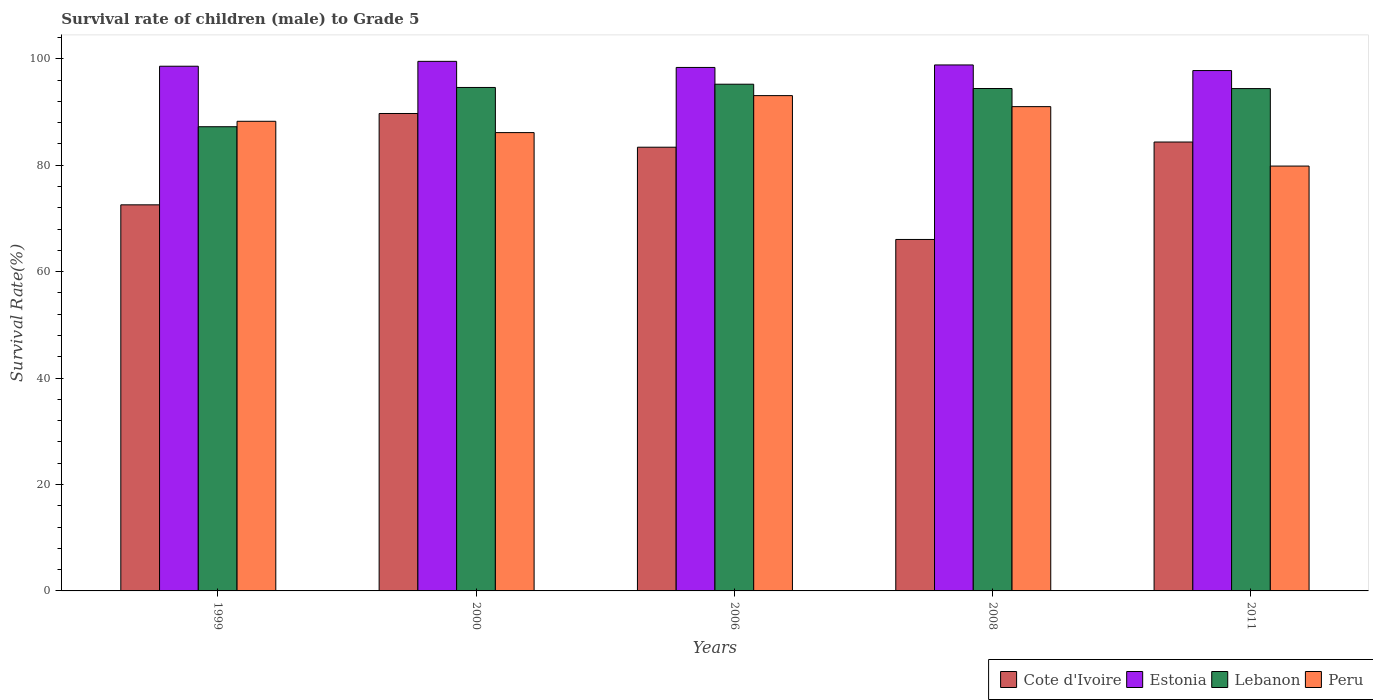How many bars are there on the 4th tick from the left?
Provide a succinct answer. 4. In how many cases, is the number of bars for a given year not equal to the number of legend labels?
Make the answer very short. 0. What is the survival rate of male children to grade 5 in Peru in 1999?
Offer a very short reply. 88.24. Across all years, what is the maximum survival rate of male children to grade 5 in Estonia?
Your answer should be compact. 99.51. Across all years, what is the minimum survival rate of male children to grade 5 in Estonia?
Your answer should be compact. 97.78. In which year was the survival rate of male children to grade 5 in Peru minimum?
Provide a short and direct response. 2011. What is the total survival rate of male children to grade 5 in Peru in the graph?
Your answer should be very brief. 438.26. What is the difference between the survival rate of male children to grade 5 in Lebanon in 1999 and that in 2000?
Make the answer very short. -7.38. What is the difference between the survival rate of male children to grade 5 in Peru in 2011 and the survival rate of male children to grade 5 in Cote d'Ivoire in 2006?
Your answer should be very brief. -3.54. What is the average survival rate of male children to grade 5 in Estonia per year?
Keep it short and to the point. 98.61. In the year 2008, what is the difference between the survival rate of male children to grade 5 in Peru and survival rate of male children to grade 5 in Lebanon?
Keep it short and to the point. -3.41. What is the ratio of the survival rate of male children to grade 5 in Cote d'Ivoire in 1999 to that in 2000?
Provide a succinct answer. 0.81. Is the survival rate of male children to grade 5 in Estonia in 2008 less than that in 2011?
Keep it short and to the point. No. What is the difference between the highest and the second highest survival rate of male children to grade 5 in Lebanon?
Provide a succinct answer. 0.61. What is the difference between the highest and the lowest survival rate of male children to grade 5 in Peru?
Offer a very short reply. 13.24. In how many years, is the survival rate of male children to grade 5 in Lebanon greater than the average survival rate of male children to grade 5 in Lebanon taken over all years?
Ensure brevity in your answer.  4. Is the sum of the survival rate of male children to grade 5 in Peru in 1999 and 2000 greater than the maximum survival rate of male children to grade 5 in Cote d'Ivoire across all years?
Your answer should be compact. Yes. Is it the case that in every year, the sum of the survival rate of male children to grade 5 in Estonia and survival rate of male children to grade 5 in Lebanon is greater than the sum of survival rate of male children to grade 5 in Peru and survival rate of male children to grade 5 in Cote d'Ivoire?
Make the answer very short. No. What does the 1st bar from the left in 2006 represents?
Your response must be concise. Cote d'Ivoire. Are all the bars in the graph horizontal?
Your answer should be compact. No. Are the values on the major ticks of Y-axis written in scientific E-notation?
Provide a short and direct response. No. How many legend labels are there?
Keep it short and to the point. 4. How are the legend labels stacked?
Offer a terse response. Horizontal. What is the title of the graph?
Your answer should be very brief. Survival rate of children (male) to Grade 5. Does "United Arab Emirates" appear as one of the legend labels in the graph?
Your response must be concise. No. What is the label or title of the Y-axis?
Ensure brevity in your answer.  Survival Rate(%). What is the Survival Rate(%) of Cote d'Ivoire in 1999?
Offer a very short reply. 72.55. What is the Survival Rate(%) in Estonia in 1999?
Provide a short and direct response. 98.59. What is the Survival Rate(%) in Lebanon in 1999?
Provide a short and direct response. 87.22. What is the Survival Rate(%) in Peru in 1999?
Provide a succinct answer. 88.24. What is the Survival Rate(%) of Cote d'Ivoire in 2000?
Your response must be concise. 89.71. What is the Survival Rate(%) in Estonia in 2000?
Offer a very short reply. 99.51. What is the Survival Rate(%) of Lebanon in 2000?
Ensure brevity in your answer.  94.6. What is the Survival Rate(%) in Peru in 2000?
Offer a terse response. 86.12. What is the Survival Rate(%) in Cote d'Ivoire in 2006?
Provide a succinct answer. 83.37. What is the Survival Rate(%) of Estonia in 2006?
Offer a very short reply. 98.36. What is the Survival Rate(%) in Lebanon in 2006?
Your answer should be compact. 95.21. What is the Survival Rate(%) of Peru in 2006?
Your answer should be very brief. 93.07. What is the Survival Rate(%) of Cote d'Ivoire in 2008?
Ensure brevity in your answer.  66.04. What is the Survival Rate(%) of Estonia in 2008?
Keep it short and to the point. 98.83. What is the Survival Rate(%) of Lebanon in 2008?
Your answer should be very brief. 94.4. What is the Survival Rate(%) in Peru in 2008?
Your answer should be compact. 91. What is the Survival Rate(%) in Cote d'Ivoire in 2011?
Offer a terse response. 84.35. What is the Survival Rate(%) of Estonia in 2011?
Offer a terse response. 97.78. What is the Survival Rate(%) of Lebanon in 2011?
Your answer should be very brief. 94.39. What is the Survival Rate(%) in Peru in 2011?
Give a very brief answer. 79.83. Across all years, what is the maximum Survival Rate(%) of Cote d'Ivoire?
Ensure brevity in your answer.  89.71. Across all years, what is the maximum Survival Rate(%) of Estonia?
Offer a very short reply. 99.51. Across all years, what is the maximum Survival Rate(%) in Lebanon?
Offer a very short reply. 95.21. Across all years, what is the maximum Survival Rate(%) in Peru?
Provide a succinct answer. 93.07. Across all years, what is the minimum Survival Rate(%) in Cote d'Ivoire?
Make the answer very short. 66.04. Across all years, what is the minimum Survival Rate(%) in Estonia?
Your answer should be compact. 97.78. Across all years, what is the minimum Survival Rate(%) in Lebanon?
Make the answer very short. 87.22. Across all years, what is the minimum Survival Rate(%) in Peru?
Keep it short and to the point. 79.83. What is the total Survival Rate(%) of Cote d'Ivoire in the graph?
Provide a short and direct response. 396.02. What is the total Survival Rate(%) in Estonia in the graph?
Ensure brevity in your answer.  493.06. What is the total Survival Rate(%) of Lebanon in the graph?
Provide a succinct answer. 465.83. What is the total Survival Rate(%) of Peru in the graph?
Provide a succinct answer. 438.26. What is the difference between the Survival Rate(%) of Cote d'Ivoire in 1999 and that in 2000?
Give a very brief answer. -17.16. What is the difference between the Survival Rate(%) of Estonia in 1999 and that in 2000?
Provide a succinct answer. -0.92. What is the difference between the Survival Rate(%) of Lebanon in 1999 and that in 2000?
Your answer should be very brief. -7.38. What is the difference between the Survival Rate(%) in Peru in 1999 and that in 2000?
Offer a terse response. 2.13. What is the difference between the Survival Rate(%) in Cote d'Ivoire in 1999 and that in 2006?
Provide a succinct answer. -10.83. What is the difference between the Survival Rate(%) of Estonia in 1999 and that in 2006?
Offer a terse response. 0.23. What is the difference between the Survival Rate(%) in Lebanon in 1999 and that in 2006?
Offer a terse response. -7.99. What is the difference between the Survival Rate(%) in Peru in 1999 and that in 2006?
Give a very brief answer. -4.82. What is the difference between the Survival Rate(%) in Cote d'Ivoire in 1999 and that in 2008?
Ensure brevity in your answer.  6.51. What is the difference between the Survival Rate(%) in Estonia in 1999 and that in 2008?
Ensure brevity in your answer.  -0.24. What is the difference between the Survival Rate(%) in Lebanon in 1999 and that in 2008?
Offer a very short reply. -7.18. What is the difference between the Survival Rate(%) of Peru in 1999 and that in 2008?
Keep it short and to the point. -2.75. What is the difference between the Survival Rate(%) in Cote d'Ivoire in 1999 and that in 2011?
Your answer should be very brief. -11.8. What is the difference between the Survival Rate(%) in Estonia in 1999 and that in 2011?
Ensure brevity in your answer.  0.81. What is the difference between the Survival Rate(%) in Lebanon in 1999 and that in 2011?
Make the answer very short. -7.17. What is the difference between the Survival Rate(%) of Peru in 1999 and that in 2011?
Make the answer very short. 8.41. What is the difference between the Survival Rate(%) in Cote d'Ivoire in 2000 and that in 2006?
Your response must be concise. 6.34. What is the difference between the Survival Rate(%) in Estonia in 2000 and that in 2006?
Offer a terse response. 1.15. What is the difference between the Survival Rate(%) in Lebanon in 2000 and that in 2006?
Keep it short and to the point. -0.61. What is the difference between the Survival Rate(%) in Peru in 2000 and that in 2006?
Offer a terse response. -6.95. What is the difference between the Survival Rate(%) of Cote d'Ivoire in 2000 and that in 2008?
Make the answer very short. 23.67. What is the difference between the Survival Rate(%) of Estonia in 2000 and that in 2008?
Keep it short and to the point. 0.67. What is the difference between the Survival Rate(%) of Lebanon in 2000 and that in 2008?
Your response must be concise. 0.19. What is the difference between the Survival Rate(%) of Peru in 2000 and that in 2008?
Offer a very short reply. -4.88. What is the difference between the Survival Rate(%) in Cote d'Ivoire in 2000 and that in 2011?
Provide a short and direct response. 5.36. What is the difference between the Survival Rate(%) in Estonia in 2000 and that in 2011?
Keep it short and to the point. 1.73. What is the difference between the Survival Rate(%) in Lebanon in 2000 and that in 2011?
Offer a very short reply. 0.21. What is the difference between the Survival Rate(%) of Peru in 2000 and that in 2011?
Provide a short and direct response. 6.29. What is the difference between the Survival Rate(%) of Cote d'Ivoire in 2006 and that in 2008?
Provide a succinct answer. 17.33. What is the difference between the Survival Rate(%) of Estonia in 2006 and that in 2008?
Keep it short and to the point. -0.47. What is the difference between the Survival Rate(%) of Lebanon in 2006 and that in 2008?
Keep it short and to the point. 0.81. What is the difference between the Survival Rate(%) of Peru in 2006 and that in 2008?
Keep it short and to the point. 2.07. What is the difference between the Survival Rate(%) of Cote d'Ivoire in 2006 and that in 2011?
Ensure brevity in your answer.  -0.97. What is the difference between the Survival Rate(%) in Estonia in 2006 and that in 2011?
Your answer should be very brief. 0.58. What is the difference between the Survival Rate(%) in Lebanon in 2006 and that in 2011?
Keep it short and to the point. 0.82. What is the difference between the Survival Rate(%) in Peru in 2006 and that in 2011?
Provide a short and direct response. 13.24. What is the difference between the Survival Rate(%) in Cote d'Ivoire in 2008 and that in 2011?
Keep it short and to the point. -18.31. What is the difference between the Survival Rate(%) of Estonia in 2008 and that in 2011?
Provide a short and direct response. 1.05. What is the difference between the Survival Rate(%) in Lebanon in 2008 and that in 2011?
Offer a terse response. 0.01. What is the difference between the Survival Rate(%) in Peru in 2008 and that in 2011?
Give a very brief answer. 11.17. What is the difference between the Survival Rate(%) of Cote d'Ivoire in 1999 and the Survival Rate(%) of Estonia in 2000?
Make the answer very short. -26.96. What is the difference between the Survival Rate(%) in Cote d'Ivoire in 1999 and the Survival Rate(%) in Lebanon in 2000?
Offer a very short reply. -22.05. What is the difference between the Survival Rate(%) of Cote d'Ivoire in 1999 and the Survival Rate(%) of Peru in 2000?
Give a very brief answer. -13.57. What is the difference between the Survival Rate(%) of Estonia in 1999 and the Survival Rate(%) of Lebanon in 2000?
Ensure brevity in your answer.  3.99. What is the difference between the Survival Rate(%) of Estonia in 1999 and the Survival Rate(%) of Peru in 2000?
Ensure brevity in your answer.  12.47. What is the difference between the Survival Rate(%) of Lebanon in 1999 and the Survival Rate(%) of Peru in 2000?
Make the answer very short. 1.1. What is the difference between the Survival Rate(%) of Cote d'Ivoire in 1999 and the Survival Rate(%) of Estonia in 2006?
Offer a terse response. -25.81. What is the difference between the Survival Rate(%) of Cote d'Ivoire in 1999 and the Survival Rate(%) of Lebanon in 2006?
Offer a very short reply. -22.67. What is the difference between the Survival Rate(%) of Cote d'Ivoire in 1999 and the Survival Rate(%) of Peru in 2006?
Ensure brevity in your answer.  -20.52. What is the difference between the Survival Rate(%) of Estonia in 1999 and the Survival Rate(%) of Lebanon in 2006?
Make the answer very short. 3.38. What is the difference between the Survival Rate(%) in Estonia in 1999 and the Survival Rate(%) in Peru in 2006?
Give a very brief answer. 5.52. What is the difference between the Survival Rate(%) in Lebanon in 1999 and the Survival Rate(%) in Peru in 2006?
Ensure brevity in your answer.  -5.85. What is the difference between the Survival Rate(%) in Cote d'Ivoire in 1999 and the Survival Rate(%) in Estonia in 2008?
Ensure brevity in your answer.  -26.29. What is the difference between the Survival Rate(%) of Cote d'Ivoire in 1999 and the Survival Rate(%) of Lebanon in 2008?
Offer a terse response. -21.86. What is the difference between the Survival Rate(%) in Cote d'Ivoire in 1999 and the Survival Rate(%) in Peru in 2008?
Your response must be concise. -18.45. What is the difference between the Survival Rate(%) of Estonia in 1999 and the Survival Rate(%) of Lebanon in 2008?
Offer a very short reply. 4.18. What is the difference between the Survival Rate(%) in Estonia in 1999 and the Survival Rate(%) in Peru in 2008?
Provide a short and direct response. 7.59. What is the difference between the Survival Rate(%) of Lebanon in 1999 and the Survival Rate(%) of Peru in 2008?
Your answer should be compact. -3.78. What is the difference between the Survival Rate(%) in Cote d'Ivoire in 1999 and the Survival Rate(%) in Estonia in 2011?
Ensure brevity in your answer.  -25.23. What is the difference between the Survival Rate(%) of Cote d'Ivoire in 1999 and the Survival Rate(%) of Lebanon in 2011?
Keep it short and to the point. -21.84. What is the difference between the Survival Rate(%) in Cote d'Ivoire in 1999 and the Survival Rate(%) in Peru in 2011?
Provide a short and direct response. -7.28. What is the difference between the Survival Rate(%) in Estonia in 1999 and the Survival Rate(%) in Lebanon in 2011?
Provide a short and direct response. 4.2. What is the difference between the Survival Rate(%) in Estonia in 1999 and the Survival Rate(%) in Peru in 2011?
Offer a terse response. 18.76. What is the difference between the Survival Rate(%) of Lebanon in 1999 and the Survival Rate(%) of Peru in 2011?
Your response must be concise. 7.39. What is the difference between the Survival Rate(%) in Cote d'Ivoire in 2000 and the Survival Rate(%) in Estonia in 2006?
Provide a short and direct response. -8.65. What is the difference between the Survival Rate(%) in Cote d'Ivoire in 2000 and the Survival Rate(%) in Lebanon in 2006?
Give a very brief answer. -5.5. What is the difference between the Survival Rate(%) of Cote d'Ivoire in 2000 and the Survival Rate(%) of Peru in 2006?
Provide a succinct answer. -3.36. What is the difference between the Survival Rate(%) of Estonia in 2000 and the Survival Rate(%) of Lebanon in 2006?
Your response must be concise. 4.29. What is the difference between the Survival Rate(%) of Estonia in 2000 and the Survival Rate(%) of Peru in 2006?
Offer a very short reply. 6.44. What is the difference between the Survival Rate(%) in Lebanon in 2000 and the Survival Rate(%) in Peru in 2006?
Your response must be concise. 1.53. What is the difference between the Survival Rate(%) of Cote d'Ivoire in 2000 and the Survival Rate(%) of Estonia in 2008?
Offer a terse response. -9.12. What is the difference between the Survival Rate(%) in Cote d'Ivoire in 2000 and the Survival Rate(%) in Lebanon in 2008?
Provide a short and direct response. -4.7. What is the difference between the Survival Rate(%) of Cote d'Ivoire in 2000 and the Survival Rate(%) of Peru in 2008?
Offer a terse response. -1.29. What is the difference between the Survival Rate(%) in Estonia in 2000 and the Survival Rate(%) in Lebanon in 2008?
Give a very brief answer. 5.1. What is the difference between the Survival Rate(%) of Estonia in 2000 and the Survival Rate(%) of Peru in 2008?
Your response must be concise. 8.51. What is the difference between the Survival Rate(%) of Lebanon in 2000 and the Survival Rate(%) of Peru in 2008?
Ensure brevity in your answer.  3.6. What is the difference between the Survival Rate(%) of Cote d'Ivoire in 2000 and the Survival Rate(%) of Estonia in 2011?
Ensure brevity in your answer.  -8.07. What is the difference between the Survival Rate(%) in Cote d'Ivoire in 2000 and the Survival Rate(%) in Lebanon in 2011?
Your response must be concise. -4.68. What is the difference between the Survival Rate(%) of Cote d'Ivoire in 2000 and the Survival Rate(%) of Peru in 2011?
Provide a short and direct response. 9.88. What is the difference between the Survival Rate(%) of Estonia in 2000 and the Survival Rate(%) of Lebanon in 2011?
Your answer should be very brief. 5.12. What is the difference between the Survival Rate(%) in Estonia in 2000 and the Survival Rate(%) in Peru in 2011?
Your response must be concise. 19.68. What is the difference between the Survival Rate(%) of Lebanon in 2000 and the Survival Rate(%) of Peru in 2011?
Make the answer very short. 14.77. What is the difference between the Survival Rate(%) in Cote d'Ivoire in 2006 and the Survival Rate(%) in Estonia in 2008?
Offer a terse response. -15.46. What is the difference between the Survival Rate(%) of Cote d'Ivoire in 2006 and the Survival Rate(%) of Lebanon in 2008?
Offer a very short reply. -11.03. What is the difference between the Survival Rate(%) in Cote d'Ivoire in 2006 and the Survival Rate(%) in Peru in 2008?
Provide a short and direct response. -7.63. What is the difference between the Survival Rate(%) of Estonia in 2006 and the Survival Rate(%) of Lebanon in 2008?
Your response must be concise. 3.96. What is the difference between the Survival Rate(%) of Estonia in 2006 and the Survival Rate(%) of Peru in 2008?
Give a very brief answer. 7.36. What is the difference between the Survival Rate(%) in Lebanon in 2006 and the Survival Rate(%) in Peru in 2008?
Ensure brevity in your answer.  4.21. What is the difference between the Survival Rate(%) of Cote d'Ivoire in 2006 and the Survival Rate(%) of Estonia in 2011?
Your response must be concise. -14.41. What is the difference between the Survival Rate(%) of Cote d'Ivoire in 2006 and the Survival Rate(%) of Lebanon in 2011?
Ensure brevity in your answer.  -11.02. What is the difference between the Survival Rate(%) in Cote d'Ivoire in 2006 and the Survival Rate(%) in Peru in 2011?
Make the answer very short. 3.54. What is the difference between the Survival Rate(%) of Estonia in 2006 and the Survival Rate(%) of Lebanon in 2011?
Make the answer very short. 3.97. What is the difference between the Survival Rate(%) of Estonia in 2006 and the Survival Rate(%) of Peru in 2011?
Make the answer very short. 18.53. What is the difference between the Survival Rate(%) of Lebanon in 2006 and the Survival Rate(%) of Peru in 2011?
Make the answer very short. 15.38. What is the difference between the Survival Rate(%) in Cote d'Ivoire in 2008 and the Survival Rate(%) in Estonia in 2011?
Ensure brevity in your answer.  -31.74. What is the difference between the Survival Rate(%) in Cote d'Ivoire in 2008 and the Survival Rate(%) in Lebanon in 2011?
Make the answer very short. -28.35. What is the difference between the Survival Rate(%) of Cote d'Ivoire in 2008 and the Survival Rate(%) of Peru in 2011?
Keep it short and to the point. -13.79. What is the difference between the Survival Rate(%) in Estonia in 2008 and the Survival Rate(%) in Lebanon in 2011?
Your answer should be very brief. 4.44. What is the difference between the Survival Rate(%) of Estonia in 2008 and the Survival Rate(%) of Peru in 2011?
Your answer should be very brief. 19. What is the difference between the Survival Rate(%) in Lebanon in 2008 and the Survival Rate(%) in Peru in 2011?
Make the answer very short. 14.57. What is the average Survival Rate(%) of Cote d'Ivoire per year?
Ensure brevity in your answer.  79.2. What is the average Survival Rate(%) in Estonia per year?
Provide a succinct answer. 98.61. What is the average Survival Rate(%) in Lebanon per year?
Make the answer very short. 93.17. What is the average Survival Rate(%) in Peru per year?
Offer a terse response. 87.65. In the year 1999, what is the difference between the Survival Rate(%) in Cote d'Ivoire and Survival Rate(%) in Estonia?
Ensure brevity in your answer.  -26.04. In the year 1999, what is the difference between the Survival Rate(%) in Cote d'Ivoire and Survival Rate(%) in Lebanon?
Give a very brief answer. -14.68. In the year 1999, what is the difference between the Survival Rate(%) in Cote d'Ivoire and Survival Rate(%) in Peru?
Your answer should be very brief. -15.7. In the year 1999, what is the difference between the Survival Rate(%) in Estonia and Survival Rate(%) in Lebanon?
Offer a very short reply. 11.37. In the year 1999, what is the difference between the Survival Rate(%) of Estonia and Survival Rate(%) of Peru?
Provide a succinct answer. 10.35. In the year 1999, what is the difference between the Survival Rate(%) in Lebanon and Survival Rate(%) in Peru?
Offer a terse response. -1.02. In the year 2000, what is the difference between the Survival Rate(%) in Cote d'Ivoire and Survival Rate(%) in Estonia?
Your answer should be compact. -9.8. In the year 2000, what is the difference between the Survival Rate(%) of Cote d'Ivoire and Survival Rate(%) of Lebanon?
Provide a succinct answer. -4.89. In the year 2000, what is the difference between the Survival Rate(%) of Cote d'Ivoire and Survival Rate(%) of Peru?
Offer a very short reply. 3.59. In the year 2000, what is the difference between the Survival Rate(%) of Estonia and Survival Rate(%) of Lebanon?
Ensure brevity in your answer.  4.91. In the year 2000, what is the difference between the Survival Rate(%) in Estonia and Survival Rate(%) in Peru?
Provide a short and direct response. 13.39. In the year 2000, what is the difference between the Survival Rate(%) of Lebanon and Survival Rate(%) of Peru?
Ensure brevity in your answer.  8.48. In the year 2006, what is the difference between the Survival Rate(%) in Cote d'Ivoire and Survival Rate(%) in Estonia?
Your answer should be very brief. -14.99. In the year 2006, what is the difference between the Survival Rate(%) in Cote d'Ivoire and Survival Rate(%) in Lebanon?
Your response must be concise. -11.84. In the year 2006, what is the difference between the Survival Rate(%) in Cote d'Ivoire and Survival Rate(%) in Peru?
Your response must be concise. -9.7. In the year 2006, what is the difference between the Survival Rate(%) of Estonia and Survival Rate(%) of Lebanon?
Provide a succinct answer. 3.15. In the year 2006, what is the difference between the Survival Rate(%) of Estonia and Survival Rate(%) of Peru?
Offer a terse response. 5.29. In the year 2006, what is the difference between the Survival Rate(%) in Lebanon and Survival Rate(%) in Peru?
Your answer should be compact. 2.14. In the year 2008, what is the difference between the Survival Rate(%) in Cote d'Ivoire and Survival Rate(%) in Estonia?
Offer a terse response. -32.79. In the year 2008, what is the difference between the Survival Rate(%) of Cote d'Ivoire and Survival Rate(%) of Lebanon?
Give a very brief answer. -28.36. In the year 2008, what is the difference between the Survival Rate(%) of Cote d'Ivoire and Survival Rate(%) of Peru?
Offer a very short reply. -24.96. In the year 2008, what is the difference between the Survival Rate(%) of Estonia and Survival Rate(%) of Lebanon?
Offer a terse response. 4.43. In the year 2008, what is the difference between the Survival Rate(%) in Estonia and Survival Rate(%) in Peru?
Ensure brevity in your answer.  7.83. In the year 2008, what is the difference between the Survival Rate(%) in Lebanon and Survival Rate(%) in Peru?
Your answer should be very brief. 3.41. In the year 2011, what is the difference between the Survival Rate(%) of Cote d'Ivoire and Survival Rate(%) of Estonia?
Give a very brief answer. -13.43. In the year 2011, what is the difference between the Survival Rate(%) of Cote d'Ivoire and Survival Rate(%) of Lebanon?
Ensure brevity in your answer.  -10.04. In the year 2011, what is the difference between the Survival Rate(%) in Cote d'Ivoire and Survival Rate(%) in Peru?
Keep it short and to the point. 4.52. In the year 2011, what is the difference between the Survival Rate(%) in Estonia and Survival Rate(%) in Lebanon?
Provide a succinct answer. 3.39. In the year 2011, what is the difference between the Survival Rate(%) in Estonia and Survival Rate(%) in Peru?
Offer a very short reply. 17.95. In the year 2011, what is the difference between the Survival Rate(%) in Lebanon and Survival Rate(%) in Peru?
Provide a short and direct response. 14.56. What is the ratio of the Survival Rate(%) in Cote d'Ivoire in 1999 to that in 2000?
Provide a short and direct response. 0.81. What is the ratio of the Survival Rate(%) of Lebanon in 1999 to that in 2000?
Your answer should be very brief. 0.92. What is the ratio of the Survival Rate(%) in Peru in 1999 to that in 2000?
Offer a terse response. 1.02. What is the ratio of the Survival Rate(%) in Cote d'Ivoire in 1999 to that in 2006?
Your answer should be compact. 0.87. What is the ratio of the Survival Rate(%) in Lebanon in 1999 to that in 2006?
Offer a very short reply. 0.92. What is the ratio of the Survival Rate(%) of Peru in 1999 to that in 2006?
Provide a short and direct response. 0.95. What is the ratio of the Survival Rate(%) of Cote d'Ivoire in 1999 to that in 2008?
Offer a terse response. 1.1. What is the ratio of the Survival Rate(%) in Lebanon in 1999 to that in 2008?
Your answer should be compact. 0.92. What is the ratio of the Survival Rate(%) in Peru in 1999 to that in 2008?
Your response must be concise. 0.97. What is the ratio of the Survival Rate(%) of Cote d'Ivoire in 1999 to that in 2011?
Ensure brevity in your answer.  0.86. What is the ratio of the Survival Rate(%) in Estonia in 1999 to that in 2011?
Your answer should be very brief. 1.01. What is the ratio of the Survival Rate(%) in Lebanon in 1999 to that in 2011?
Your answer should be very brief. 0.92. What is the ratio of the Survival Rate(%) in Peru in 1999 to that in 2011?
Offer a very short reply. 1.11. What is the ratio of the Survival Rate(%) in Cote d'Ivoire in 2000 to that in 2006?
Your response must be concise. 1.08. What is the ratio of the Survival Rate(%) in Estonia in 2000 to that in 2006?
Your answer should be compact. 1.01. What is the ratio of the Survival Rate(%) in Peru in 2000 to that in 2006?
Provide a short and direct response. 0.93. What is the ratio of the Survival Rate(%) in Cote d'Ivoire in 2000 to that in 2008?
Give a very brief answer. 1.36. What is the ratio of the Survival Rate(%) in Estonia in 2000 to that in 2008?
Offer a very short reply. 1.01. What is the ratio of the Survival Rate(%) in Peru in 2000 to that in 2008?
Make the answer very short. 0.95. What is the ratio of the Survival Rate(%) in Cote d'Ivoire in 2000 to that in 2011?
Ensure brevity in your answer.  1.06. What is the ratio of the Survival Rate(%) of Estonia in 2000 to that in 2011?
Provide a short and direct response. 1.02. What is the ratio of the Survival Rate(%) of Peru in 2000 to that in 2011?
Offer a terse response. 1.08. What is the ratio of the Survival Rate(%) of Cote d'Ivoire in 2006 to that in 2008?
Your response must be concise. 1.26. What is the ratio of the Survival Rate(%) in Lebanon in 2006 to that in 2008?
Your response must be concise. 1.01. What is the ratio of the Survival Rate(%) of Peru in 2006 to that in 2008?
Provide a succinct answer. 1.02. What is the ratio of the Survival Rate(%) in Cote d'Ivoire in 2006 to that in 2011?
Your response must be concise. 0.99. What is the ratio of the Survival Rate(%) of Lebanon in 2006 to that in 2011?
Ensure brevity in your answer.  1.01. What is the ratio of the Survival Rate(%) in Peru in 2006 to that in 2011?
Ensure brevity in your answer.  1.17. What is the ratio of the Survival Rate(%) in Cote d'Ivoire in 2008 to that in 2011?
Keep it short and to the point. 0.78. What is the ratio of the Survival Rate(%) of Estonia in 2008 to that in 2011?
Provide a succinct answer. 1.01. What is the ratio of the Survival Rate(%) of Lebanon in 2008 to that in 2011?
Offer a terse response. 1. What is the ratio of the Survival Rate(%) of Peru in 2008 to that in 2011?
Offer a terse response. 1.14. What is the difference between the highest and the second highest Survival Rate(%) of Cote d'Ivoire?
Provide a succinct answer. 5.36. What is the difference between the highest and the second highest Survival Rate(%) of Estonia?
Provide a succinct answer. 0.67. What is the difference between the highest and the second highest Survival Rate(%) of Lebanon?
Offer a terse response. 0.61. What is the difference between the highest and the second highest Survival Rate(%) in Peru?
Offer a very short reply. 2.07. What is the difference between the highest and the lowest Survival Rate(%) in Cote d'Ivoire?
Ensure brevity in your answer.  23.67. What is the difference between the highest and the lowest Survival Rate(%) of Estonia?
Ensure brevity in your answer.  1.73. What is the difference between the highest and the lowest Survival Rate(%) of Lebanon?
Your response must be concise. 7.99. What is the difference between the highest and the lowest Survival Rate(%) of Peru?
Offer a very short reply. 13.24. 